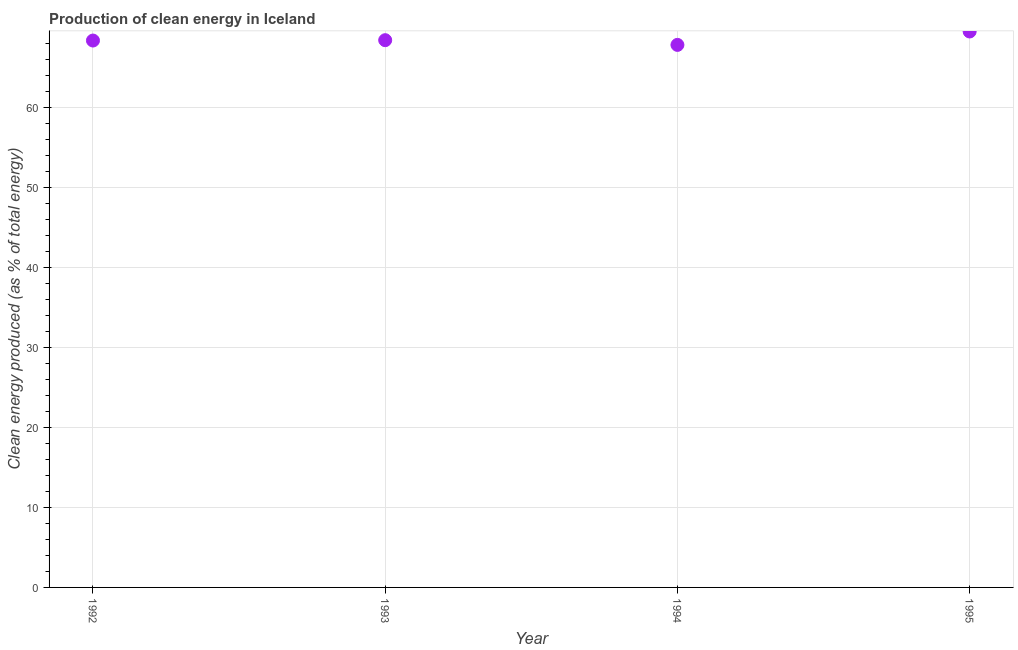What is the production of clean energy in 1994?
Ensure brevity in your answer.  67.77. Across all years, what is the maximum production of clean energy?
Make the answer very short. 69.44. Across all years, what is the minimum production of clean energy?
Your answer should be very brief. 67.77. In which year was the production of clean energy maximum?
Make the answer very short. 1995. In which year was the production of clean energy minimum?
Keep it short and to the point. 1994. What is the sum of the production of clean energy?
Offer a terse response. 273.88. What is the difference between the production of clean energy in 1992 and 1993?
Offer a very short reply. -0.04. What is the average production of clean energy per year?
Offer a very short reply. 68.47. What is the median production of clean energy?
Your answer should be very brief. 68.33. In how many years, is the production of clean energy greater than 8 %?
Provide a succinct answer. 4. What is the ratio of the production of clean energy in 1993 to that in 1994?
Your answer should be very brief. 1.01. Is the production of clean energy in 1992 less than that in 1993?
Give a very brief answer. Yes. What is the difference between the highest and the second highest production of clean energy?
Provide a short and direct response. 1.09. What is the difference between the highest and the lowest production of clean energy?
Your response must be concise. 1.67. Does the production of clean energy monotonically increase over the years?
Your answer should be compact. No. How many dotlines are there?
Make the answer very short. 1. How many years are there in the graph?
Provide a succinct answer. 4. What is the difference between two consecutive major ticks on the Y-axis?
Provide a short and direct response. 10. Does the graph contain any zero values?
Offer a terse response. No. What is the title of the graph?
Your answer should be compact. Production of clean energy in Iceland. What is the label or title of the Y-axis?
Offer a very short reply. Clean energy produced (as % of total energy). What is the Clean energy produced (as % of total energy) in 1992?
Provide a short and direct response. 68.31. What is the Clean energy produced (as % of total energy) in 1993?
Provide a short and direct response. 68.36. What is the Clean energy produced (as % of total energy) in 1994?
Give a very brief answer. 67.77. What is the Clean energy produced (as % of total energy) in 1995?
Offer a terse response. 69.44. What is the difference between the Clean energy produced (as % of total energy) in 1992 and 1993?
Your response must be concise. -0.04. What is the difference between the Clean energy produced (as % of total energy) in 1992 and 1994?
Keep it short and to the point. 0.54. What is the difference between the Clean energy produced (as % of total energy) in 1992 and 1995?
Keep it short and to the point. -1.13. What is the difference between the Clean energy produced (as % of total energy) in 1993 and 1994?
Offer a very short reply. 0.59. What is the difference between the Clean energy produced (as % of total energy) in 1993 and 1995?
Keep it short and to the point. -1.09. What is the difference between the Clean energy produced (as % of total energy) in 1994 and 1995?
Provide a short and direct response. -1.67. What is the ratio of the Clean energy produced (as % of total energy) in 1993 to that in 1994?
Keep it short and to the point. 1.01. 